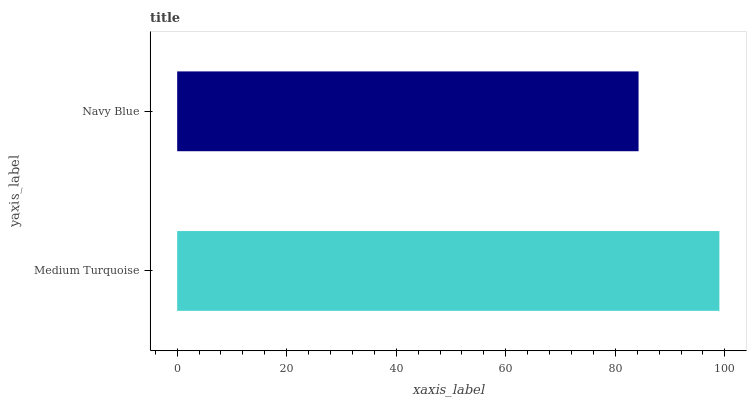Is Navy Blue the minimum?
Answer yes or no. Yes. Is Medium Turquoise the maximum?
Answer yes or no. Yes. Is Navy Blue the maximum?
Answer yes or no. No. Is Medium Turquoise greater than Navy Blue?
Answer yes or no. Yes. Is Navy Blue less than Medium Turquoise?
Answer yes or no. Yes. Is Navy Blue greater than Medium Turquoise?
Answer yes or no. No. Is Medium Turquoise less than Navy Blue?
Answer yes or no. No. Is Medium Turquoise the high median?
Answer yes or no. Yes. Is Navy Blue the low median?
Answer yes or no. Yes. Is Navy Blue the high median?
Answer yes or no. No. Is Medium Turquoise the low median?
Answer yes or no. No. 